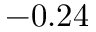Convert formula to latex. <formula><loc_0><loc_0><loc_500><loc_500>- 0 . 2 4</formula> 